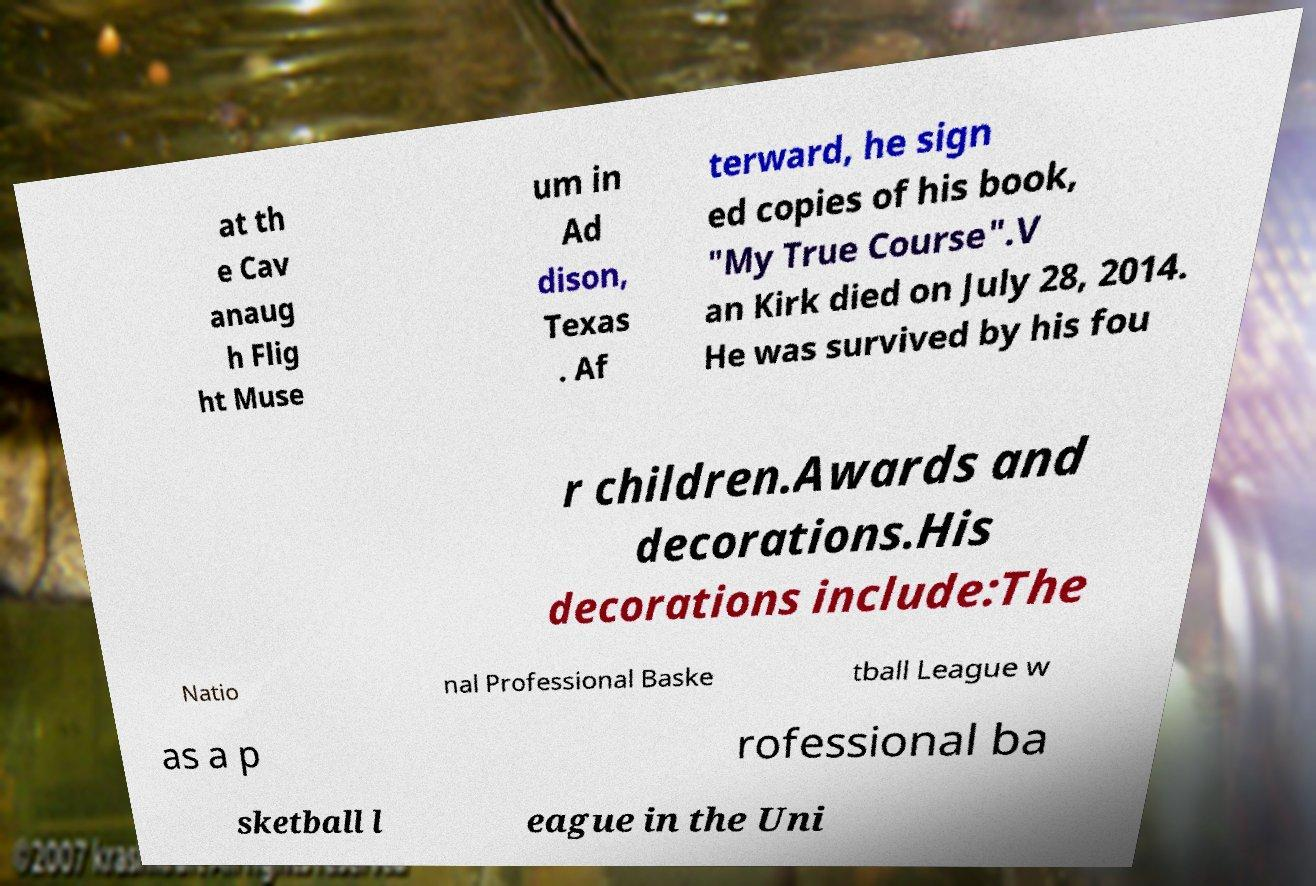There's text embedded in this image that I need extracted. Can you transcribe it verbatim? at th e Cav anaug h Flig ht Muse um in Ad dison, Texas . Af terward, he sign ed copies of his book, "My True Course".V an Kirk died on July 28, 2014. He was survived by his fou r children.Awards and decorations.His decorations include:The Natio nal Professional Baske tball League w as a p rofessional ba sketball l eague in the Uni 